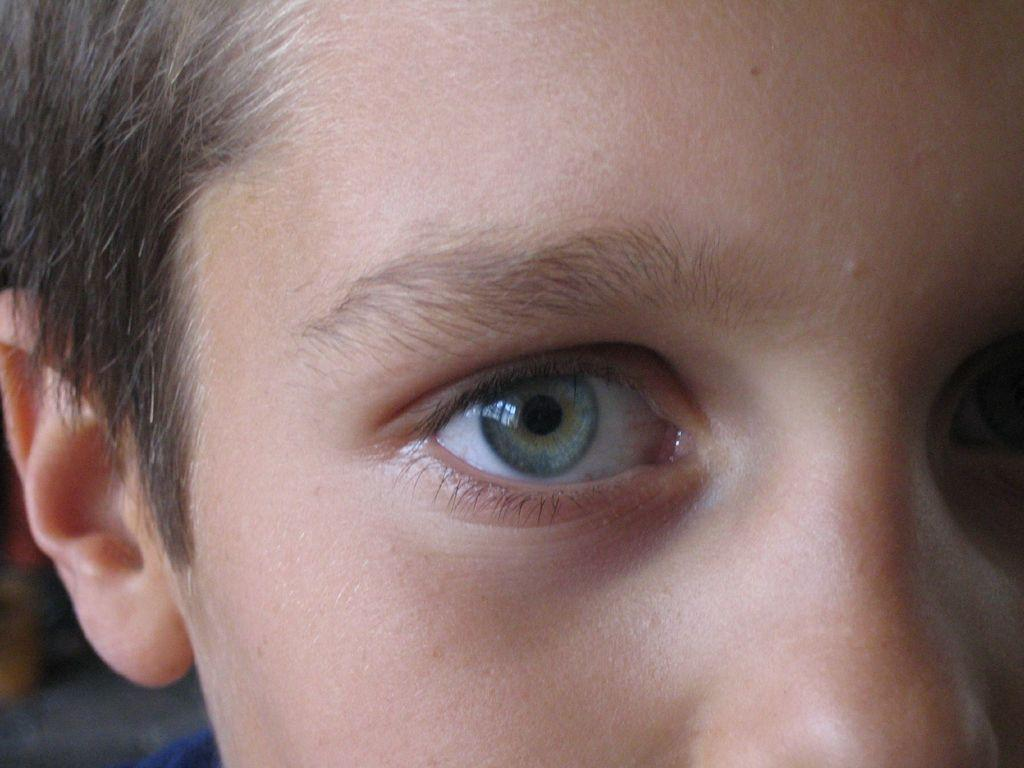What is the main subject of the image? There is a person's face in the image. What else can be seen in the image besides the person's face? There are objects in the image. Can you describe the setting where the image might have been taken? The image may have been taken in a room. What type of roof can be seen in the image? There is no roof present in the image. How many horses are visible in the image? There are no horses present in the image. 